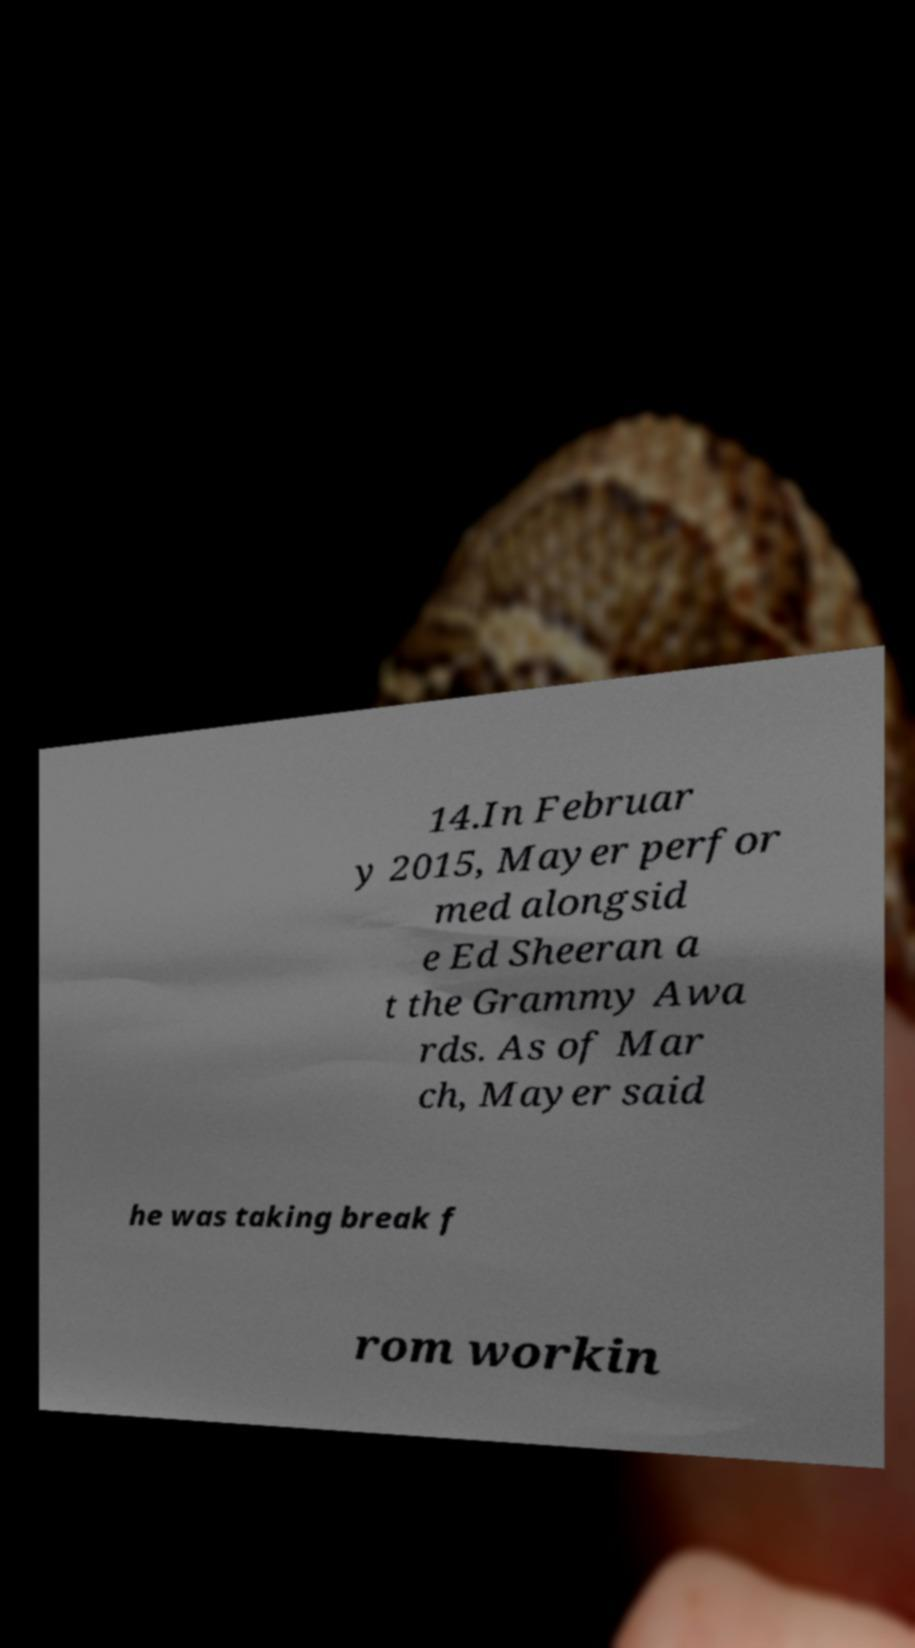Could you extract and type out the text from this image? 14.In Februar y 2015, Mayer perfor med alongsid e Ed Sheeran a t the Grammy Awa rds. As of Mar ch, Mayer said he was taking break f rom workin 